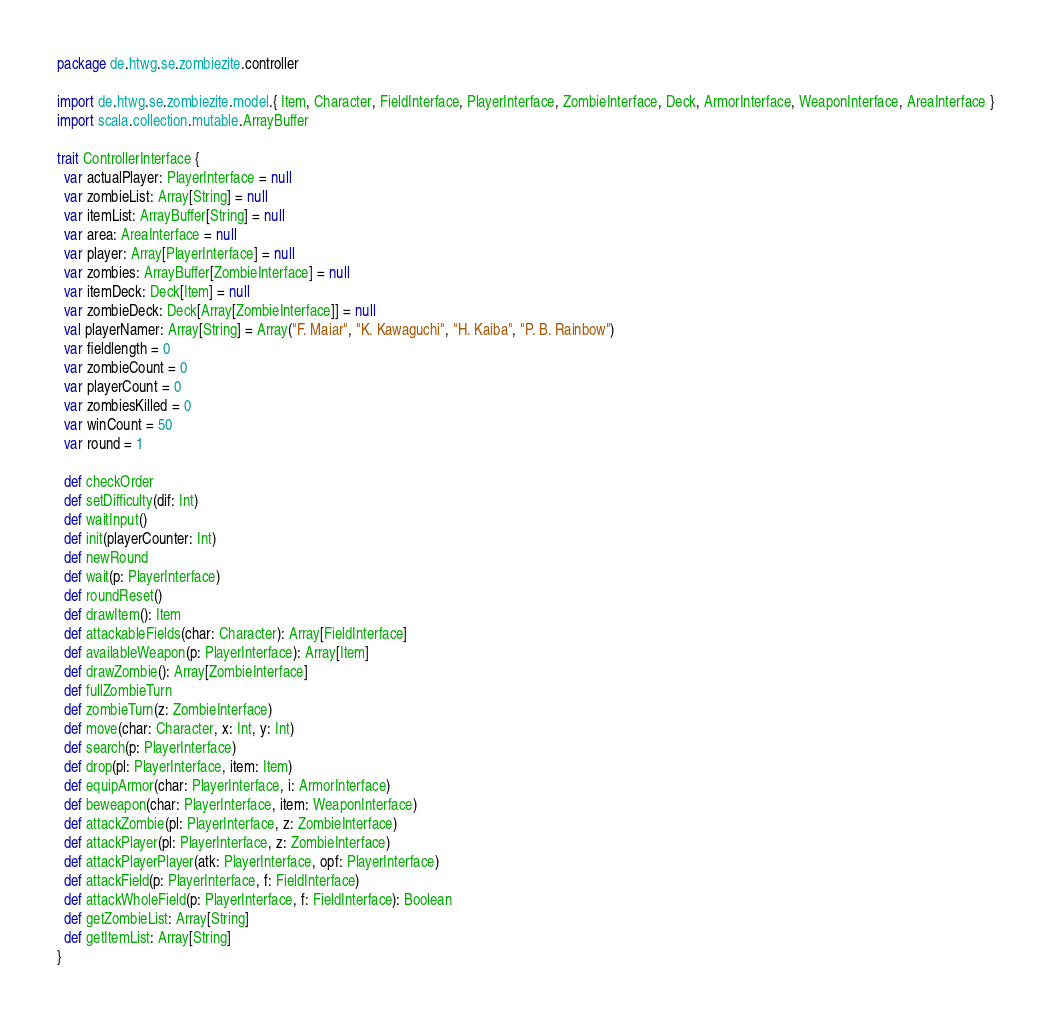Convert code to text. <code><loc_0><loc_0><loc_500><loc_500><_Scala_>package de.htwg.se.zombiezite.controller

import de.htwg.se.zombiezite.model.{ Item, Character, FieldInterface, PlayerInterface, ZombieInterface, Deck, ArmorInterface, WeaponInterface, AreaInterface }
import scala.collection.mutable.ArrayBuffer

trait ControllerInterface {
  var actualPlayer: PlayerInterface = null
  var zombieList: Array[String] = null
  var itemList: ArrayBuffer[String] = null
  var area: AreaInterface = null
  var player: Array[PlayerInterface] = null
  var zombies: ArrayBuffer[ZombieInterface] = null
  var itemDeck: Deck[Item] = null
  var zombieDeck: Deck[Array[ZombieInterface]] = null
  val playerNamer: Array[String] = Array("F. Maiar", "K. Kawaguchi", "H. Kaiba", "P. B. Rainbow")
  var fieldlength = 0
  var zombieCount = 0
  var playerCount = 0
  var zombiesKilled = 0
  var winCount = 50
  var round = 1

  def checkOrder
  def setDifficulty(dif: Int)
  def waitInput()
  def init(playerCounter: Int)
  def newRound
  def wait(p: PlayerInterface)
  def roundReset()
  def drawItem(): Item
  def attackableFields(char: Character): Array[FieldInterface]
  def availableWeapon(p: PlayerInterface): Array[Item]
  def drawZombie(): Array[ZombieInterface]
  def fullZombieTurn
  def zombieTurn(z: ZombieInterface)
  def move(char: Character, x: Int, y: Int)
  def search(p: PlayerInterface)
  def drop(pl: PlayerInterface, item: Item)
  def equipArmor(char: PlayerInterface, i: ArmorInterface)
  def beweapon(char: PlayerInterface, item: WeaponInterface)
  def attackZombie(pl: PlayerInterface, z: ZombieInterface)
  def attackPlayer(pl: PlayerInterface, z: ZombieInterface)
  def attackPlayerPlayer(atk: PlayerInterface, opf: PlayerInterface)
  def attackField(p: PlayerInterface, f: FieldInterface)
  def attackWholeField(p: PlayerInterface, f: FieldInterface): Boolean
  def getZombieList: Array[String]
  def getItemList: Array[String]
}</code> 